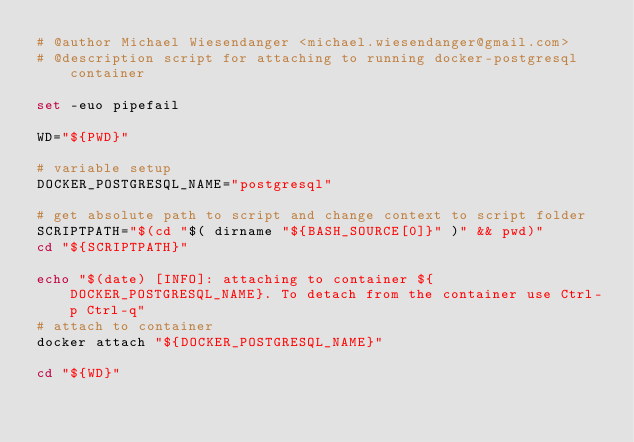<code> <loc_0><loc_0><loc_500><loc_500><_Bash_># @author Michael Wiesendanger <michael.wiesendanger@gmail.com>
# @description script for attaching to running docker-postgresql container

set -euo pipefail

WD="${PWD}"

# variable setup
DOCKER_POSTGRESQL_NAME="postgresql"

# get absolute path to script and change context to script folder
SCRIPTPATH="$(cd "$( dirname "${BASH_SOURCE[0]}" )" && pwd)"
cd "${SCRIPTPATH}"

echo "$(date) [INFO]: attaching to container ${DOCKER_POSTGRESQL_NAME}. To detach from the container use Ctrl-p Ctrl-q"
# attach to container
docker attach "${DOCKER_POSTGRESQL_NAME}"

cd "${WD}"
</code> 